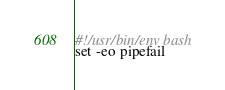Convert code to text. <code><loc_0><loc_0><loc_500><loc_500><_Bash_>#!/usr/bin/env bash
set -eo pipefail
</code> 